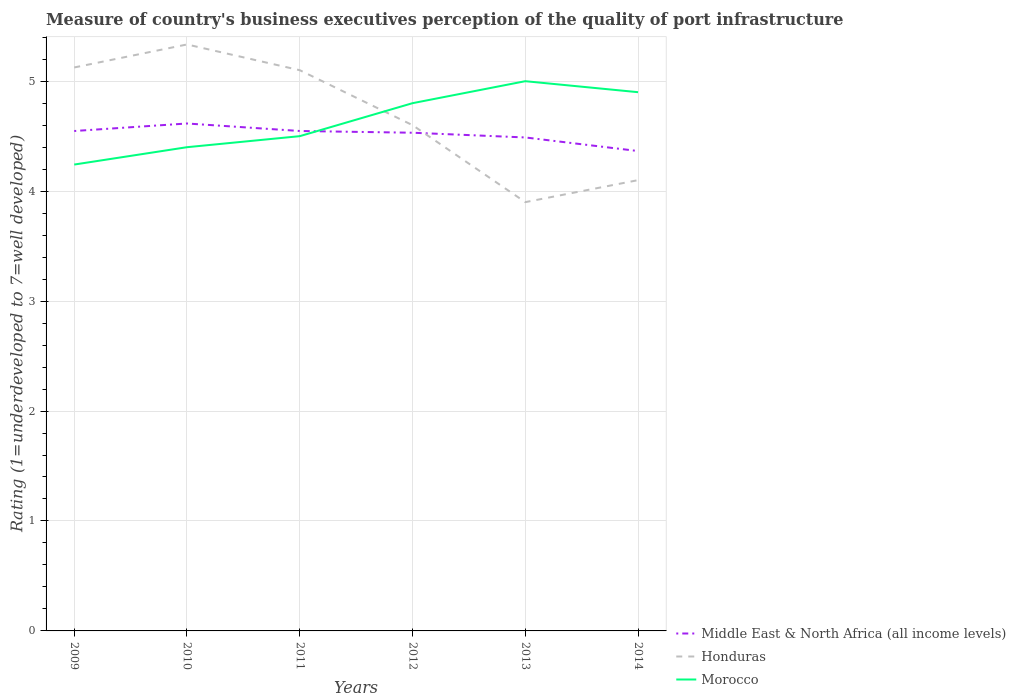Across all years, what is the maximum ratings of the quality of port infrastructure in Honduras?
Provide a short and direct response. 3.9. What is the total ratings of the quality of port infrastructure in Honduras in the graph?
Offer a very short reply. 0.02. What is the difference between the highest and the second highest ratings of the quality of port infrastructure in Middle East & North Africa (all income levels)?
Offer a very short reply. 0.25. Is the ratings of the quality of port infrastructure in Honduras strictly greater than the ratings of the quality of port infrastructure in Morocco over the years?
Ensure brevity in your answer.  No. How many years are there in the graph?
Keep it short and to the point. 6. Where does the legend appear in the graph?
Provide a short and direct response. Bottom right. How many legend labels are there?
Provide a succinct answer. 3. How are the legend labels stacked?
Give a very brief answer. Vertical. What is the title of the graph?
Provide a short and direct response. Measure of country's business executives perception of the quality of port infrastructure. What is the label or title of the Y-axis?
Make the answer very short. Rating (1=underdeveloped to 7=well developed). What is the Rating (1=underdeveloped to 7=well developed) in Middle East & North Africa (all income levels) in 2009?
Ensure brevity in your answer.  4.55. What is the Rating (1=underdeveloped to 7=well developed) in Honduras in 2009?
Ensure brevity in your answer.  5.12. What is the Rating (1=underdeveloped to 7=well developed) in Morocco in 2009?
Provide a succinct answer. 4.24. What is the Rating (1=underdeveloped to 7=well developed) of Middle East & North Africa (all income levels) in 2010?
Offer a terse response. 4.62. What is the Rating (1=underdeveloped to 7=well developed) in Honduras in 2010?
Provide a succinct answer. 5.33. What is the Rating (1=underdeveloped to 7=well developed) of Morocco in 2010?
Ensure brevity in your answer.  4.4. What is the Rating (1=underdeveloped to 7=well developed) in Middle East & North Africa (all income levels) in 2011?
Your response must be concise. 4.55. What is the Rating (1=underdeveloped to 7=well developed) in Morocco in 2011?
Make the answer very short. 4.5. What is the Rating (1=underdeveloped to 7=well developed) in Middle East & North Africa (all income levels) in 2012?
Provide a succinct answer. 4.53. What is the Rating (1=underdeveloped to 7=well developed) in Honduras in 2012?
Offer a very short reply. 4.6. What is the Rating (1=underdeveloped to 7=well developed) in Middle East & North Africa (all income levels) in 2013?
Ensure brevity in your answer.  4.49. What is the Rating (1=underdeveloped to 7=well developed) in Honduras in 2013?
Keep it short and to the point. 3.9. What is the Rating (1=underdeveloped to 7=well developed) in Middle East & North Africa (all income levels) in 2014?
Keep it short and to the point. 4.36. Across all years, what is the maximum Rating (1=underdeveloped to 7=well developed) in Middle East & North Africa (all income levels)?
Offer a terse response. 4.62. Across all years, what is the maximum Rating (1=underdeveloped to 7=well developed) of Honduras?
Your response must be concise. 5.33. Across all years, what is the minimum Rating (1=underdeveloped to 7=well developed) in Middle East & North Africa (all income levels)?
Offer a terse response. 4.36. Across all years, what is the minimum Rating (1=underdeveloped to 7=well developed) of Morocco?
Provide a short and direct response. 4.24. What is the total Rating (1=underdeveloped to 7=well developed) of Middle East & North Africa (all income levels) in the graph?
Ensure brevity in your answer.  27.09. What is the total Rating (1=underdeveloped to 7=well developed) of Honduras in the graph?
Ensure brevity in your answer.  28.16. What is the total Rating (1=underdeveloped to 7=well developed) in Morocco in the graph?
Your answer should be very brief. 27.84. What is the difference between the Rating (1=underdeveloped to 7=well developed) of Middle East & North Africa (all income levels) in 2009 and that in 2010?
Your response must be concise. -0.07. What is the difference between the Rating (1=underdeveloped to 7=well developed) of Honduras in 2009 and that in 2010?
Your response must be concise. -0.21. What is the difference between the Rating (1=underdeveloped to 7=well developed) of Morocco in 2009 and that in 2010?
Provide a succinct answer. -0.16. What is the difference between the Rating (1=underdeveloped to 7=well developed) in Middle East & North Africa (all income levels) in 2009 and that in 2011?
Keep it short and to the point. -0. What is the difference between the Rating (1=underdeveloped to 7=well developed) in Honduras in 2009 and that in 2011?
Provide a succinct answer. 0.02. What is the difference between the Rating (1=underdeveloped to 7=well developed) of Morocco in 2009 and that in 2011?
Your answer should be compact. -0.26. What is the difference between the Rating (1=underdeveloped to 7=well developed) in Middle East & North Africa (all income levels) in 2009 and that in 2012?
Offer a terse response. 0.02. What is the difference between the Rating (1=underdeveloped to 7=well developed) of Honduras in 2009 and that in 2012?
Ensure brevity in your answer.  0.52. What is the difference between the Rating (1=underdeveloped to 7=well developed) of Morocco in 2009 and that in 2012?
Provide a short and direct response. -0.56. What is the difference between the Rating (1=underdeveloped to 7=well developed) of Middle East & North Africa (all income levels) in 2009 and that in 2013?
Your answer should be very brief. 0.06. What is the difference between the Rating (1=underdeveloped to 7=well developed) in Honduras in 2009 and that in 2013?
Provide a short and direct response. 1.22. What is the difference between the Rating (1=underdeveloped to 7=well developed) of Morocco in 2009 and that in 2013?
Give a very brief answer. -0.76. What is the difference between the Rating (1=underdeveloped to 7=well developed) in Middle East & North Africa (all income levels) in 2009 and that in 2014?
Your answer should be compact. 0.18. What is the difference between the Rating (1=underdeveloped to 7=well developed) in Honduras in 2009 and that in 2014?
Make the answer very short. 1.02. What is the difference between the Rating (1=underdeveloped to 7=well developed) of Morocco in 2009 and that in 2014?
Offer a very short reply. -0.66. What is the difference between the Rating (1=underdeveloped to 7=well developed) of Middle East & North Africa (all income levels) in 2010 and that in 2011?
Your answer should be very brief. 0.07. What is the difference between the Rating (1=underdeveloped to 7=well developed) in Honduras in 2010 and that in 2011?
Your response must be concise. 0.23. What is the difference between the Rating (1=underdeveloped to 7=well developed) of Morocco in 2010 and that in 2011?
Offer a terse response. -0.1. What is the difference between the Rating (1=underdeveloped to 7=well developed) in Middle East & North Africa (all income levels) in 2010 and that in 2012?
Your answer should be very brief. 0.08. What is the difference between the Rating (1=underdeveloped to 7=well developed) of Honduras in 2010 and that in 2012?
Give a very brief answer. 0.73. What is the difference between the Rating (1=underdeveloped to 7=well developed) of Morocco in 2010 and that in 2012?
Ensure brevity in your answer.  -0.4. What is the difference between the Rating (1=underdeveloped to 7=well developed) of Middle East & North Africa (all income levels) in 2010 and that in 2013?
Your answer should be compact. 0.13. What is the difference between the Rating (1=underdeveloped to 7=well developed) of Honduras in 2010 and that in 2013?
Keep it short and to the point. 1.43. What is the difference between the Rating (1=underdeveloped to 7=well developed) in Morocco in 2010 and that in 2013?
Your answer should be compact. -0.6. What is the difference between the Rating (1=underdeveloped to 7=well developed) in Middle East & North Africa (all income levels) in 2010 and that in 2014?
Make the answer very short. 0.25. What is the difference between the Rating (1=underdeveloped to 7=well developed) of Honduras in 2010 and that in 2014?
Offer a terse response. 1.23. What is the difference between the Rating (1=underdeveloped to 7=well developed) of Morocco in 2010 and that in 2014?
Your answer should be very brief. -0.5. What is the difference between the Rating (1=underdeveloped to 7=well developed) in Middle East & North Africa (all income levels) in 2011 and that in 2012?
Keep it short and to the point. 0.02. What is the difference between the Rating (1=underdeveloped to 7=well developed) of Middle East & North Africa (all income levels) in 2011 and that in 2013?
Your answer should be compact. 0.06. What is the difference between the Rating (1=underdeveloped to 7=well developed) in Honduras in 2011 and that in 2013?
Your response must be concise. 1.2. What is the difference between the Rating (1=underdeveloped to 7=well developed) of Morocco in 2011 and that in 2013?
Give a very brief answer. -0.5. What is the difference between the Rating (1=underdeveloped to 7=well developed) in Middle East & North Africa (all income levels) in 2011 and that in 2014?
Offer a very short reply. 0.18. What is the difference between the Rating (1=underdeveloped to 7=well developed) in Honduras in 2011 and that in 2014?
Keep it short and to the point. 1. What is the difference between the Rating (1=underdeveloped to 7=well developed) in Middle East & North Africa (all income levels) in 2012 and that in 2013?
Ensure brevity in your answer.  0.04. What is the difference between the Rating (1=underdeveloped to 7=well developed) of Morocco in 2012 and that in 2013?
Keep it short and to the point. -0.2. What is the difference between the Rating (1=underdeveloped to 7=well developed) of Middle East & North Africa (all income levels) in 2012 and that in 2014?
Offer a very short reply. 0.17. What is the difference between the Rating (1=underdeveloped to 7=well developed) of Honduras in 2012 and that in 2014?
Give a very brief answer. 0.5. What is the difference between the Rating (1=underdeveloped to 7=well developed) of Middle East & North Africa (all income levels) in 2013 and that in 2014?
Your answer should be compact. 0.12. What is the difference between the Rating (1=underdeveloped to 7=well developed) in Morocco in 2013 and that in 2014?
Your answer should be compact. 0.1. What is the difference between the Rating (1=underdeveloped to 7=well developed) in Middle East & North Africa (all income levels) in 2009 and the Rating (1=underdeveloped to 7=well developed) in Honduras in 2010?
Offer a very short reply. -0.79. What is the difference between the Rating (1=underdeveloped to 7=well developed) in Middle East & North Africa (all income levels) in 2009 and the Rating (1=underdeveloped to 7=well developed) in Morocco in 2010?
Make the answer very short. 0.15. What is the difference between the Rating (1=underdeveloped to 7=well developed) of Honduras in 2009 and the Rating (1=underdeveloped to 7=well developed) of Morocco in 2010?
Give a very brief answer. 0.73. What is the difference between the Rating (1=underdeveloped to 7=well developed) of Middle East & North Africa (all income levels) in 2009 and the Rating (1=underdeveloped to 7=well developed) of Honduras in 2011?
Give a very brief answer. -0.55. What is the difference between the Rating (1=underdeveloped to 7=well developed) of Middle East & North Africa (all income levels) in 2009 and the Rating (1=underdeveloped to 7=well developed) of Morocco in 2011?
Provide a short and direct response. 0.05. What is the difference between the Rating (1=underdeveloped to 7=well developed) of Honduras in 2009 and the Rating (1=underdeveloped to 7=well developed) of Morocco in 2011?
Offer a very short reply. 0.62. What is the difference between the Rating (1=underdeveloped to 7=well developed) in Middle East & North Africa (all income levels) in 2009 and the Rating (1=underdeveloped to 7=well developed) in Honduras in 2012?
Your answer should be very brief. -0.05. What is the difference between the Rating (1=underdeveloped to 7=well developed) of Middle East & North Africa (all income levels) in 2009 and the Rating (1=underdeveloped to 7=well developed) of Morocco in 2012?
Ensure brevity in your answer.  -0.25. What is the difference between the Rating (1=underdeveloped to 7=well developed) of Honduras in 2009 and the Rating (1=underdeveloped to 7=well developed) of Morocco in 2012?
Your response must be concise. 0.32. What is the difference between the Rating (1=underdeveloped to 7=well developed) of Middle East & North Africa (all income levels) in 2009 and the Rating (1=underdeveloped to 7=well developed) of Honduras in 2013?
Offer a terse response. 0.65. What is the difference between the Rating (1=underdeveloped to 7=well developed) of Middle East & North Africa (all income levels) in 2009 and the Rating (1=underdeveloped to 7=well developed) of Morocco in 2013?
Your answer should be compact. -0.45. What is the difference between the Rating (1=underdeveloped to 7=well developed) of Honduras in 2009 and the Rating (1=underdeveloped to 7=well developed) of Morocco in 2013?
Your answer should be very brief. 0.12. What is the difference between the Rating (1=underdeveloped to 7=well developed) of Middle East & North Africa (all income levels) in 2009 and the Rating (1=underdeveloped to 7=well developed) of Honduras in 2014?
Your answer should be very brief. 0.45. What is the difference between the Rating (1=underdeveloped to 7=well developed) in Middle East & North Africa (all income levels) in 2009 and the Rating (1=underdeveloped to 7=well developed) in Morocco in 2014?
Make the answer very short. -0.35. What is the difference between the Rating (1=underdeveloped to 7=well developed) of Honduras in 2009 and the Rating (1=underdeveloped to 7=well developed) of Morocco in 2014?
Your answer should be compact. 0.22. What is the difference between the Rating (1=underdeveloped to 7=well developed) of Middle East & North Africa (all income levels) in 2010 and the Rating (1=underdeveloped to 7=well developed) of Honduras in 2011?
Your response must be concise. -0.48. What is the difference between the Rating (1=underdeveloped to 7=well developed) of Middle East & North Africa (all income levels) in 2010 and the Rating (1=underdeveloped to 7=well developed) of Morocco in 2011?
Provide a succinct answer. 0.12. What is the difference between the Rating (1=underdeveloped to 7=well developed) of Honduras in 2010 and the Rating (1=underdeveloped to 7=well developed) of Morocco in 2011?
Offer a very short reply. 0.83. What is the difference between the Rating (1=underdeveloped to 7=well developed) in Middle East & North Africa (all income levels) in 2010 and the Rating (1=underdeveloped to 7=well developed) in Honduras in 2012?
Offer a very short reply. 0.02. What is the difference between the Rating (1=underdeveloped to 7=well developed) of Middle East & North Africa (all income levels) in 2010 and the Rating (1=underdeveloped to 7=well developed) of Morocco in 2012?
Your answer should be compact. -0.18. What is the difference between the Rating (1=underdeveloped to 7=well developed) in Honduras in 2010 and the Rating (1=underdeveloped to 7=well developed) in Morocco in 2012?
Provide a short and direct response. 0.53. What is the difference between the Rating (1=underdeveloped to 7=well developed) of Middle East & North Africa (all income levels) in 2010 and the Rating (1=underdeveloped to 7=well developed) of Honduras in 2013?
Offer a very short reply. 0.72. What is the difference between the Rating (1=underdeveloped to 7=well developed) of Middle East & North Africa (all income levels) in 2010 and the Rating (1=underdeveloped to 7=well developed) of Morocco in 2013?
Offer a terse response. -0.38. What is the difference between the Rating (1=underdeveloped to 7=well developed) in Honduras in 2010 and the Rating (1=underdeveloped to 7=well developed) in Morocco in 2013?
Ensure brevity in your answer.  0.33. What is the difference between the Rating (1=underdeveloped to 7=well developed) in Middle East & North Africa (all income levels) in 2010 and the Rating (1=underdeveloped to 7=well developed) in Honduras in 2014?
Provide a short and direct response. 0.52. What is the difference between the Rating (1=underdeveloped to 7=well developed) in Middle East & North Africa (all income levels) in 2010 and the Rating (1=underdeveloped to 7=well developed) in Morocco in 2014?
Give a very brief answer. -0.28. What is the difference between the Rating (1=underdeveloped to 7=well developed) in Honduras in 2010 and the Rating (1=underdeveloped to 7=well developed) in Morocco in 2014?
Your answer should be very brief. 0.43. What is the difference between the Rating (1=underdeveloped to 7=well developed) in Middle East & North Africa (all income levels) in 2011 and the Rating (1=underdeveloped to 7=well developed) in Honduras in 2012?
Your answer should be compact. -0.05. What is the difference between the Rating (1=underdeveloped to 7=well developed) of Middle East & North Africa (all income levels) in 2011 and the Rating (1=underdeveloped to 7=well developed) of Morocco in 2012?
Provide a short and direct response. -0.25. What is the difference between the Rating (1=underdeveloped to 7=well developed) in Honduras in 2011 and the Rating (1=underdeveloped to 7=well developed) in Morocco in 2012?
Keep it short and to the point. 0.3. What is the difference between the Rating (1=underdeveloped to 7=well developed) of Middle East & North Africa (all income levels) in 2011 and the Rating (1=underdeveloped to 7=well developed) of Honduras in 2013?
Keep it short and to the point. 0.65. What is the difference between the Rating (1=underdeveloped to 7=well developed) of Middle East & North Africa (all income levels) in 2011 and the Rating (1=underdeveloped to 7=well developed) of Morocco in 2013?
Make the answer very short. -0.45. What is the difference between the Rating (1=underdeveloped to 7=well developed) of Honduras in 2011 and the Rating (1=underdeveloped to 7=well developed) of Morocco in 2013?
Your response must be concise. 0.1. What is the difference between the Rating (1=underdeveloped to 7=well developed) of Middle East & North Africa (all income levels) in 2011 and the Rating (1=underdeveloped to 7=well developed) of Honduras in 2014?
Keep it short and to the point. 0.45. What is the difference between the Rating (1=underdeveloped to 7=well developed) of Middle East & North Africa (all income levels) in 2011 and the Rating (1=underdeveloped to 7=well developed) of Morocco in 2014?
Your answer should be compact. -0.35. What is the difference between the Rating (1=underdeveloped to 7=well developed) in Middle East & North Africa (all income levels) in 2012 and the Rating (1=underdeveloped to 7=well developed) in Honduras in 2013?
Your answer should be compact. 0.63. What is the difference between the Rating (1=underdeveloped to 7=well developed) in Middle East & North Africa (all income levels) in 2012 and the Rating (1=underdeveloped to 7=well developed) in Morocco in 2013?
Your response must be concise. -0.47. What is the difference between the Rating (1=underdeveloped to 7=well developed) in Middle East & North Africa (all income levels) in 2012 and the Rating (1=underdeveloped to 7=well developed) in Honduras in 2014?
Your answer should be very brief. 0.43. What is the difference between the Rating (1=underdeveloped to 7=well developed) in Middle East & North Africa (all income levels) in 2012 and the Rating (1=underdeveloped to 7=well developed) in Morocco in 2014?
Give a very brief answer. -0.37. What is the difference between the Rating (1=underdeveloped to 7=well developed) in Honduras in 2012 and the Rating (1=underdeveloped to 7=well developed) in Morocco in 2014?
Give a very brief answer. -0.3. What is the difference between the Rating (1=underdeveloped to 7=well developed) in Middle East & North Africa (all income levels) in 2013 and the Rating (1=underdeveloped to 7=well developed) in Honduras in 2014?
Give a very brief answer. 0.39. What is the difference between the Rating (1=underdeveloped to 7=well developed) of Middle East & North Africa (all income levels) in 2013 and the Rating (1=underdeveloped to 7=well developed) of Morocco in 2014?
Keep it short and to the point. -0.41. What is the difference between the Rating (1=underdeveloped to 7=well developed) of Honduras in 2013 and the Rating (1=underdeveloped to 7=well developed) of Morocco in 2014?
Provide a short and direct response. -1. What is the average Rating (1=underdeveloped to 7=well developed) in Middle East & North Africa (all income levels) per year?
Offer a terse response. 4.52. What is the average Rating (1=underdeveloped to 7=well developed) in Honduras per year?
Your answer should be very brief. 4.69. What is the average Rating (1=underdeveloped to 7=well developed) of Morocco per year?
Keep it short and to the point. 4.64. In the year 2009, what is the difference between the Rating (1=underdeveloped to 7=well developed) of Middle East & North Africa (all income levels) and Rating (1=underdeveloped to 7=well developed) of Honduras?
Ensure brevity in your answer.  -0.58. In the year 2009, what is the difference between the Rating (1=underdeveloped to 7=well developed) in Middle East & North Africa (all income levels) and Rating (1=underdeveloped to 7=well developed) in Morocco?
Your answer should be very brief. 0.31. In the year 2009, what is the difference between the Rating (1=underdeveloped to 7=well developed) in Honduras and Rating (1=underdeveloped to 7=well developed) in Morocco?
Your answer should be compact. 0.88. In the year 2010, what is the difference between the Rating (1=underdeveloped to 7=well developed) of Middle East & North Africa (all income levels) and Rating (1=underdeveloped to 7=well developed) of Honduras?
Provide a succinct answer. -0.72. In the year 2010, what is the difference between the Rating (1=underdeveloped to 7=well developed) in Middle East & North Africa (all income levels) and Rating (1=underdeveloped to 7=well developed) in Morocco?
Your response must be concise. 0.22. In the year 2010, what is the difference between the Rating (1=underdeveloped to 7=well developed) in Honduras and Rating (1=underdeveloped to 7=well developed) in Morocco?
Provide a succinct answer. 0.93. In the year 2011, what is the difference between the Rating (1=underdeveloped to 7=well developed) of Middle East & North Africa (all income levels) and Rating (1=underdeveloped to 7=well developed) of Honduras?
Keep it short and to the point. -0.55. In the year 2011, what is the difference between the Rating (1=underdeveloped to 7=well developed) in Middle East & North Africa (all income levels) and Rating (1=underdeveloped to 7=well developed) in Morocco?
Provide a short and direct response. 0.05. In the year 2011, what is the difference between the Rating (1=underdeveloped to 7=well developed) in Honduras and Rating (1=underdeveloped to 7=well developed) in Morocco?
Give a very brief answer. 0.6. In the year 2012, what is the difference between the Rating (1=underdeveloped to 7=well developed) in Middle East & North Africa (all income levels) and Rating (1=underdeveloped to 7=well developed) in Honduras?
Your response must be concise. -0.07. In the year 2012, what is the difference between the Rating (1=underdeveloped to 7=well developed) of Middle East & North Africa (all income levels) and Rating (1=underdeveloped to 7=well developed) of Morocco?
Provide a short and direct response. -0.27. In the year 2012, what is the difference between the Rating (1=underdeveloped to 7=well developed) in Honduras and Rating (1=underdeveloped to 7=well developed) in Morocco?
Offer a terse response. -0.2. In the year 2013, what is the difference between the Rating (1=underdeveloped to 7=well developed) in Middle East & North Africa (all income levels) and Rating (1=underdeveloped to 7=well developed) in Honduras?
Make the answer very short. 0.59. In the year 2013, what is the difference between the Rating (1=underdeveloped to 7=well developed) in Middle East & North Africa (all income levels) and Rating (1=underdeveloped to 7=well developed) in Morocco?
Give a very brief answer. -0.51. In the year 2013, what is the difference between the Rating (1=underdeveloped to 7=well developed) in Honduras and Rating (1=underdeveloped to 7=well developed) in Morocco?
Ensure brevity in your answer.  -1.1. In the year 2014, what is the difference between the Rating (1=underdeveloped to 7=well developed) in Middle East & North Africa (all income levels) and Rating (1=underdeveloped to 7=well developed) in Honduras?
Give a very brief answer. 0.26. In the year 2014, what is the difference between the Rating (1=underdeveloped to 7=well developed) in Middle East & North Africa (all income levels) and Rating (1=underdeveloped to 7=well developed) in Morocco?
Your answer should be very brief. -0.54. In the year 2014, what is the difference between the Rating (1=underdeveloped to 7=well developed) in Honduras and Rating (1=underdeveloped to 7=well developed) in Morocco?
Your answer should be very brief. -0.8. What is the ratio of the Rating (1=underdeveloped to 7=well developed) of Middle East & North Africa (all income levels) in 2009 to that in 2010?
Keep it short and to the point. 0.99. What is the ratio of the Rating (1=underdeveloped to 7=well developed) of Honduras in 2009 to that in 2010?
Offer a terse response. 0.96. What is the ratio of the Rating (1=underdeveloped to 7=well developed) in Morocco in 2009 to that in 2010?
Keep it short and to the point. 0.96. What is the ratio of the Rating (1=underdeveloped to 7=well developed) in Middle East & North Africa (all income levels) in 2009 to that in 2011?
Keep it short and to the point. 1. What is the ratio of the Rating (1=underdeveloped to 7=well developed) of Honduras in 2009 to that in 2011?
Your answer should be very brief. 1. What is the ratio of the Rating (1=underdeveloped to 7=well developed) in Morocco in 2009 to that in 2011?
Your response must be concise. 0.94. What is the ratio of the Rating (1=underdeveloped to 7=well developed) in Honduras in 2009 to that in 2012?
Provide a succinct answer. 1.11. What is the ratio of the Rating (1=underdeveloped to 7=well developed) in Morocco in 2009 to that in 2012?
Provide a short and direct response. 0.88. What is the ratio of the Rating (1=underdeveloped to 7=well developed) of Middle East & North Africa (all income levels) in 2009 to that in 2013?
Offer a terse response. 1.01. What is the ratio of the Rating (1=underdeveloped to 7=well developed) of Honduras in 2009 to that in 2013?
Make the answer very short. 1.31. What is the ratio of the Rating (1=underdeveloped to 7=well developed) of Morocco in 2009 to that in 2013?
Offer a terse response. 0.85. What is the ratio of the Rating (1=underdeveloped to 7=well developed) in Middle East & North Africa (all income levels) in 2009 to that in 2014?
Offer a very short reply. 1.04. What is the ratio of the Rating (1=underdeveloped to 7=well developed) in Honduras in 2009 to that in 2014?
Keep it short and to the point. 1.25. What is the ratio of the Rating (1=underdeveloped to 7=well developed) in Morocco in 2009 to that in 2014?
Offer a very short reply. 0.87. What is the ratio of the Rating (1=underdeveloped to 7=well developed) in Middle East & North Africa (all income levels) in 2010 to that in 2011?
Your answer should be compact. 1.01. What is the ratio of the Rating (1=underdeveloped to 7=well developed) of Honduras in 2010 to that in 2011?
Your response must be concise. 1.05. What is the ratio of the Rating (1=underdeveloped to 7=well developed) of Morocco in 2010 to that in 2011?
Give a very brief answer. 0.98. What is the ratio of the Rating (1=underdeveloped to 7=well developed) of Middle East & North Africa (all income levels) in 2010 to that in 2012?
Your answer should be very brief. 1.02. What is the ratio of the Rating (1=underdeveloped to 7=well developed) of Honduras in 2010 to that in 2012?
Your response must be concise. 1.16. What is the ratio of the Rating (1=underdeveloped to 7=well developed) of Morocco in 2010 to that in 2012?
Offer a very short reply. 0.92. What is the ratio of the Rating (1=underdeveloped to 7=well developed) of Middle East & North Africa (all income levels) in 2010 to that in 2013?
Your response must be concise. 1.03. What is the ratio of the Rating (1=underdeveloped to 7=well developed) of Honduras in 2010 to that in 2013?
Make the answer very short. 1.37. What is the ratio of the Rating (1=underdeveloped to 7=well developed) of Morocco in 2010 to that in 2013?
Offer a terse response. 0.88. What is the ratio of the Rating (1=underdeveloped to 7=well developed) in Middle East & North Africa (all income levels) in 2010 to that in 2014?
Your answer should be very brief. 1.06. What is the ratio of the Rating (1=underdeveloped to 7=well developed) of Honduras in 2010 to that in 2014?
Your answer should be very brief. 1.3. What is the ratio of the Rating (1=underdeveloped to 7=well developed) of Morocco in 2010 to that in 2014?
Provide a short and direct response. 0.9. What is the ratio of the Rating (1=underdeveloped to 7=well developed) of Honduras in 2011 to that in 2012?
Provide a succinct answer. 1.11. What is the ratio of the Rating (1=underdeveloped to 7=well developed) in Morocco in 2011 to that in 2012?
Offer a terse response. 0.94. What is the ratio of the Rating (1=underdeveloped to 7=well developed) in Middle East & North Africa (all income levels) in 2011 to that in 2013?
Your answer should be compact. 1.01. What is the ratio of the Rating (1=underdeveloped to 7=well developed) in Honduras in 2011 to that in 2013?
Your response must be concise. 1.31. What is the ratio of the Rating (1=underdeveloped to 7=well developed) of Morocco in 2011 to that in 2013?
Ensure brevity in your answer.  0.9. What is the ratio of the Rating (1=underdeveloped to 7=well developed) of Middle East & North Africa (all income levels) in 2011 to that in 2014?
Make the answer very short. 1.04. What is the ratio of the Rating (1=underdeveloped to 7=well developed) in Honduras in 2011 to that in 2014?
Make the answer very short. 1.24. What is the ratio of the Rating (1=underdeveloped to 7=well developed) in Morocco in 2011 to that in 2014?
Provide a succinct answer. 0.92. What is the ratio of the Rating (1=underdeveloped to 7=well developed) in Middle East & North Africa (all income levels) in 2012 to that in 2013?
Offer a very short reply. 1.01. What is the ratio of the Rating (1=underdeveloped to 7=well developed) of Honduras in 2012 to that in 2013?
Ensure brevity in your answer.  1.18. What is the ratio of the Rating (1=underdeveloped to 7=well developed) of Morocco in 2012 to that in 2013?
Offer a very short reply. 0.96. What is the ratio of the Rating (1=underdeveloped to 7=well developed) in Middle East & North Africa (all income levels) in 2012 to that in 2014?
Provide a succinct answer. 1.04. What is the ratio of the Rating (1=underdeveloped to 7=well developed) in Honduras in 2012 to that in 2014?
Your answer should be compact. 1.12. What is the ratio of the Rating (1=underdeveloped to 7=well developed) of Morocco in 2012 to that in 2014?
Your answer should be compact. 0.98. What is the ratio of the Rating (1=underdeveloped to 7=well developed) in Middle East & North Africa (all income levels) in 2013 to that in 2014?
Your answer should be compact. 1.03. What is the ratio of the Rating (1=underdeveloped to 7=well developed) of Honduras in 2013 to that in 2014?
Offer a very short reply. 0.95. What is the ratio of the Rating (1=underdeveloped to 7=well developed) in Morocco in 2013 to that in 2014?
Provide a short and direct response. 1.02. What is the difference between the highest and the second highest Rating (1=underdeveloped to 7=well developed) of Middle East & North Africa (all income levels)?
Your answer should be compact. 0.07. What is the difference between the highest and the second highest Rating (1=underdeveloped to 7=well developed) in Honduras?
Ensure brevity in your answer.  0.21. What is the difference between the highest and the lowest Rating (1=underdeveloped to 7=well developed) of Middle East & North Africa (all income levels)?
Offer a terse response. 0.25. What is the difference between the highest and the lowest Rating (1=underdeveloped to 7=well developed) in Honduras?
Your answer should be very brief. 1.43. What is the difference between the highest and the lowest Rating (1=underdeveloped to 7=well developed) in Morocco?
Provide a short and direct response. 0.76. 